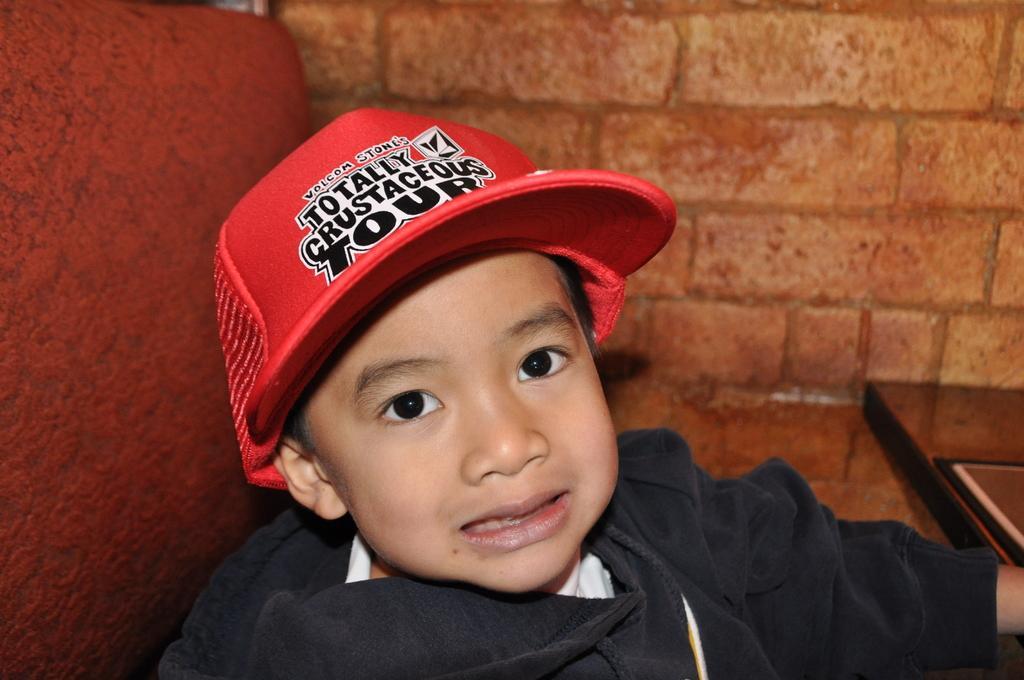Describe this image in one or two sentences. There is a child wearing a red cap. In the back there is a brick wall. On the cap something is written. 